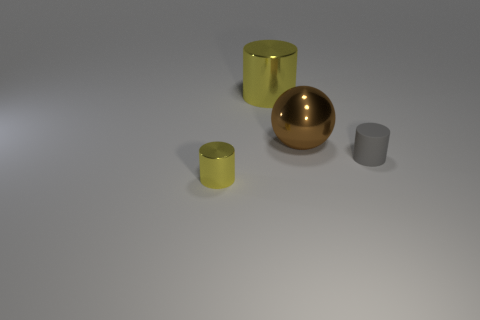How many other small cylinders are the same color as the tiny metal cylinder? 0 